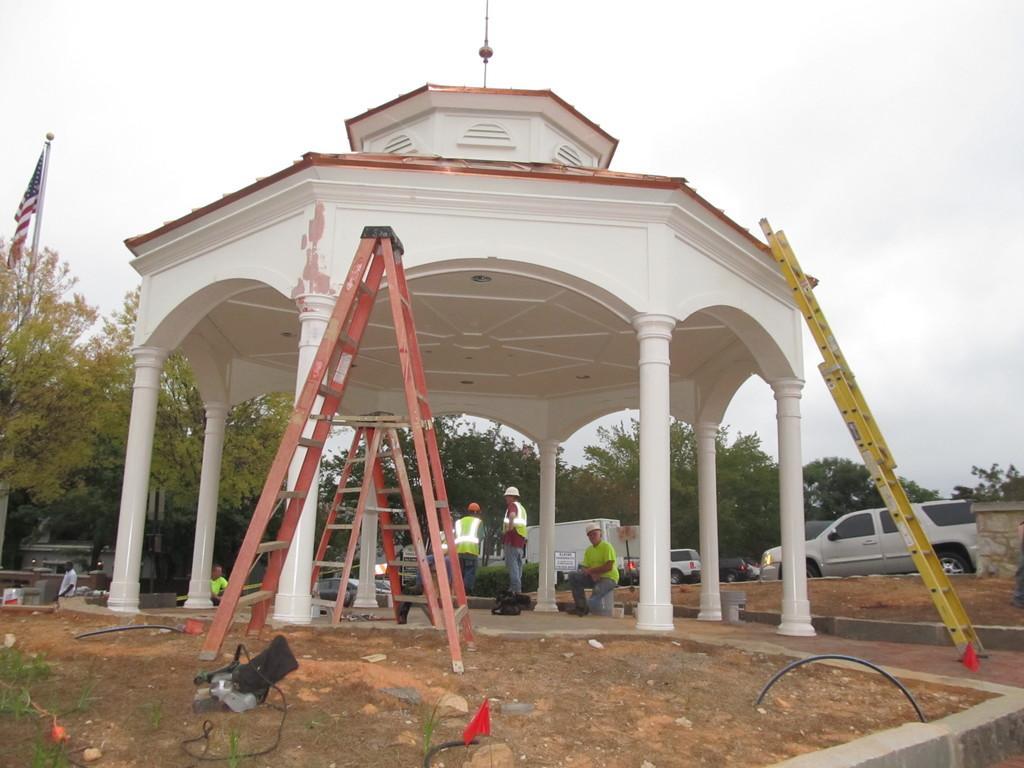Can you describe this image briefly? In this image, we can see some pillars and there is a shed, we can see some ladders, there are some people standing, we can see some cars, there is a flag on the left side, we can see some trees, at the top there is a sky. 